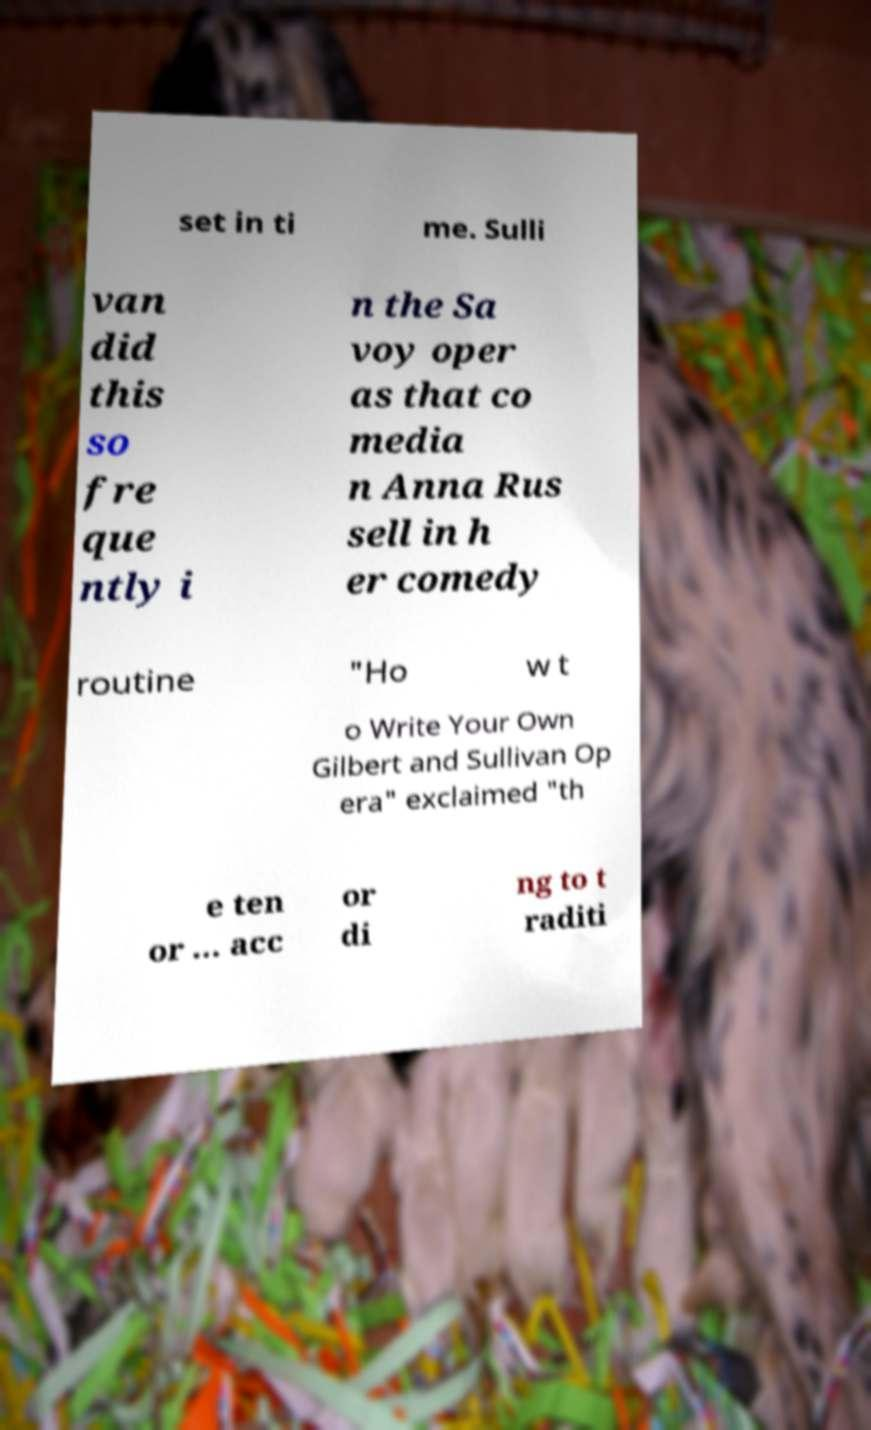Please read and relay the text visible in this image. What does it say? set in ti me. Sulli van did this so fre que ntly i n the Sa voy oper as that co media n Anna Rus sell in h er comedy routine "Ho w t o Write Your Own Gilbert and Sullivan Op era" exclaimed "th e ten or ... acc or di ng to t raditi 